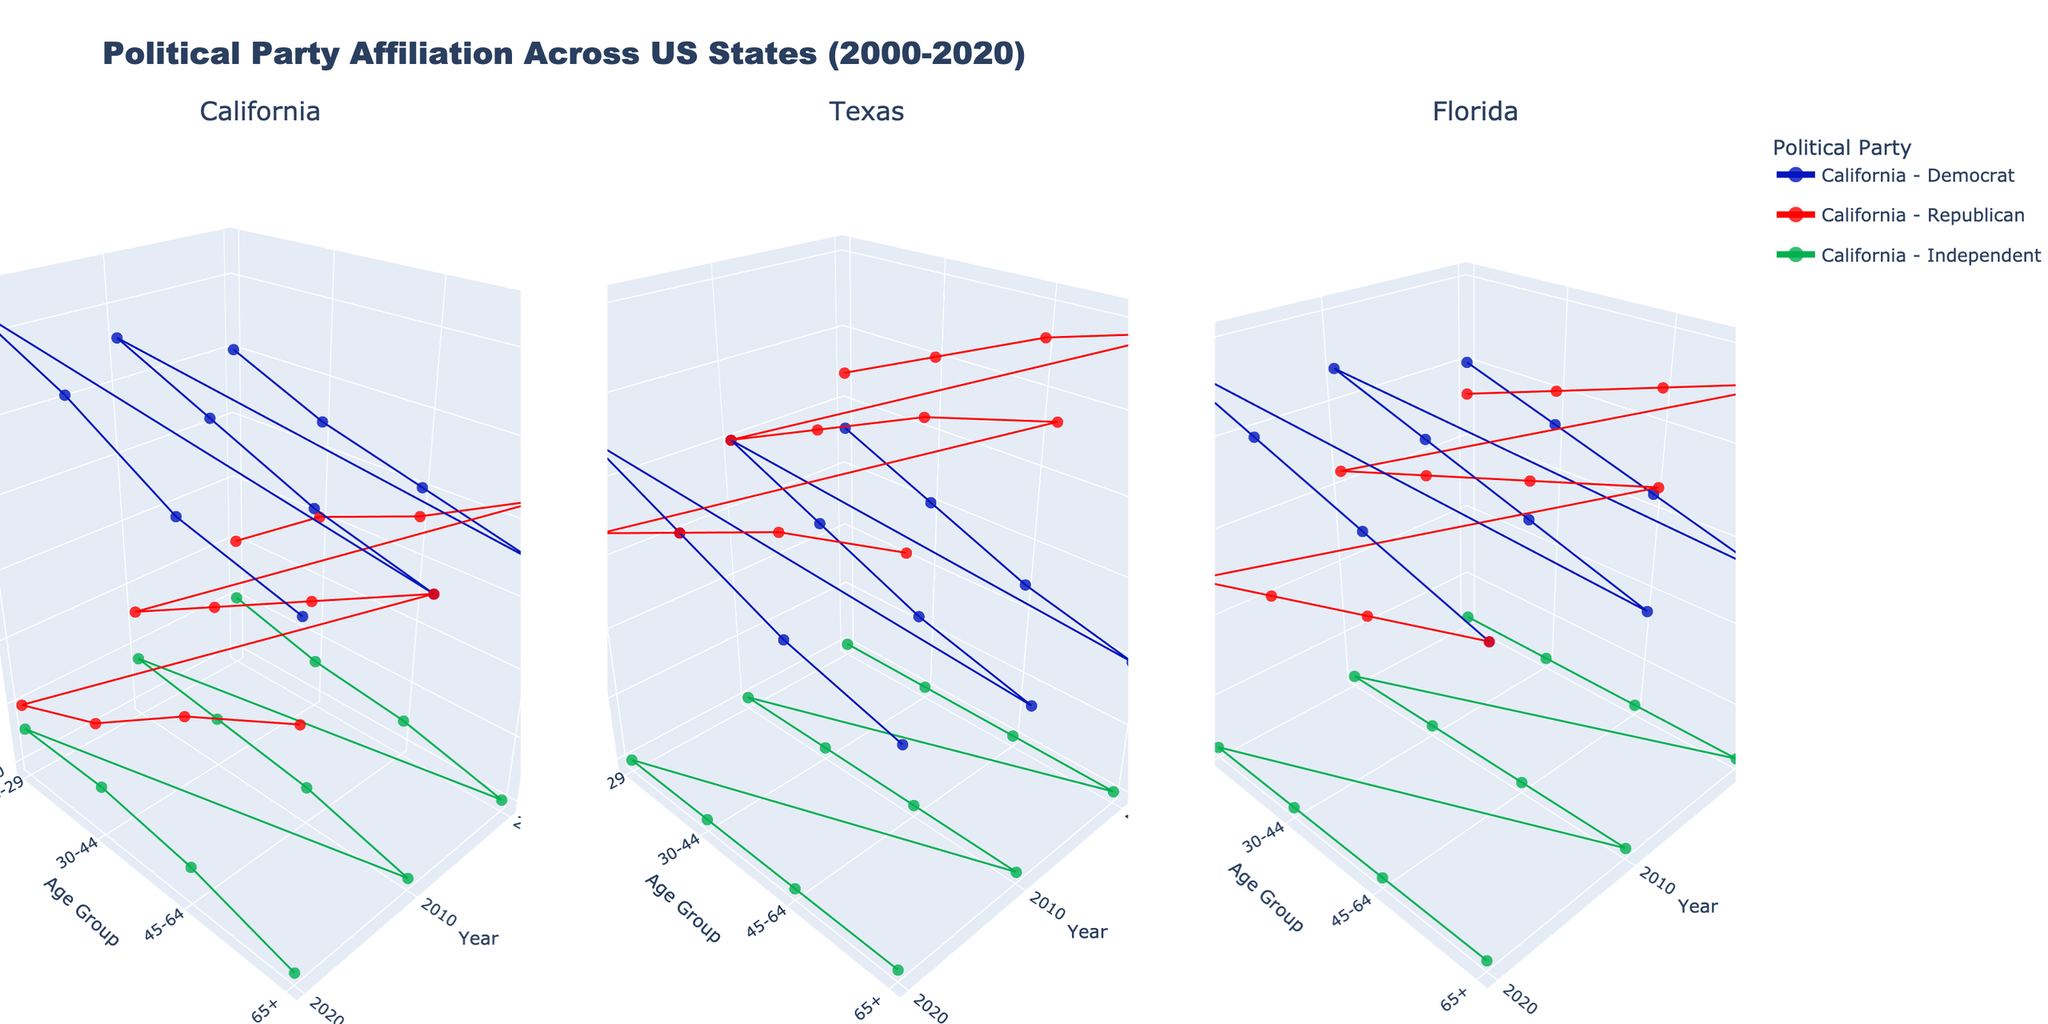How does the political affiliation of the 18-29 age group in California change from 2000 to 2020? Looking at the subplot for California, we need to identify the data points for the 18-29 age group for the years 2000, 2010, and 2020 across the Democrats, Republicans, and Independents. In 2000, Democrats are at 45%, Republicans at 30%, and Independents at 25%. By 2020, Democrats increase to 52%, Republicans decrease to 25%, and Independents remain at 23%. This indicates an increase in Democratic affiliation and a decrease in Republican affiliation over time, with Independents remaining fairly constant.
Answer: Democrat affiliation increases, Republican affiliation decreases, Independent remains constant Which state shows the highest Republican affiliation for the 65+ age group in 2020? To determine the highest Republican affiliation for the 65+ age group in 2020, we need to compare the Republican percentages from each subplot. California has 37%, Texas has 45%, and Florida has 39%. Thus, Texas shows the highest Republican affiliation for this age group in 2020.
Answer: Texas What is the average Democratic affiliation in Florida in the year 2010 across all age groups? We find the Democratic percentages in Florida for each age group in 2010: 18-29 is 42%, 30-44 is 40%, 45-64 is 38%, and 65+ is 36%. Adding these, we get 42 + 40 + 38 + 36 = 156. Dividing by the number of age groups (4) gives us an average: 156 / 4 = 39%.
Answer: 39% Compare the change in Democratic affiliation for the age group 30-44 in California and Texas from 2000 to 2020. In California, Democratic affiliation for 30-44 increases from 42% in 2000 to 49% in 2020, an increase of 7%. In Texas, it increases from 35% in 2000 to 40% in 2020, an increase of 5%. Thus, California sees a greater increase (7%) compared to Texas (5%).
Answer: California increases more For the 45-64 age group, which state shows the least change in Independent affiliation from 2000 to 2020? The Independent affiliation for the 45-64 age group in 2000 and 2020 are as follows: California (22% to 22%), Texas (20% to 20%), and Florida (22% to 22%). All three states show no change (0%) in Independent affiliation, meaning they all show the least change.
Answer: All three states (California, Texas, Florida) In 2020, which state has the highest Democratic affiliation among the 18-29 age group? We compare the Democratic affiliation for the 18-29 age group across the three states in 2020. California is at 52%, Texas is at 43%, and Florida is at 45%. Hence, California has the highest Democratic affiliation for this age group in 2020.
Answer: California What was the Republican affiliation in Texas for the 45-64 age group in 2010, and how does it compare to the Democratic affiliation for the same group and year? In Texas in 2010, the Republican affiliation for the 45-64 age group is 46%, while the Democratic affiliation is 34%. The Republicans have a higher affiliation by a difference of 12% (46% - 34%).
Answer: Republican is 46%, Democrat is 34%, difference is 12% Based on the data, which political party showed a consistent percentage within the Independent category across all states and age groups in 2020? For the Independent category in 2020, California shows 23% (18-29), 23% (30-44), 22% (45-64), and 20% (65+); Texas shows 20% across all age groups; Florida shows 22% across all age groups. Texas and Florida show a consistent percentage (20% and 22% respectively) within the Independent category across all age groups in 2020.
Answer: Texas and Florida Considering data from 2000 to 2020, which state shows the smallest change in overall Democratic affiliation across all age groups? Evaluating the overall change in Democratic affiliation from 2000 to 2020 across all age groups: California changes from an average of 41.25% (2000) to 47.25% (2020), a 6% increase. Texas changes from 33.75% to 38.75%, a 5% increase. Florida changes from 37% to 42%, a 5% increase. Both Texas and Florida show the smallest change of 5%.
Answer: Texas and Florida 